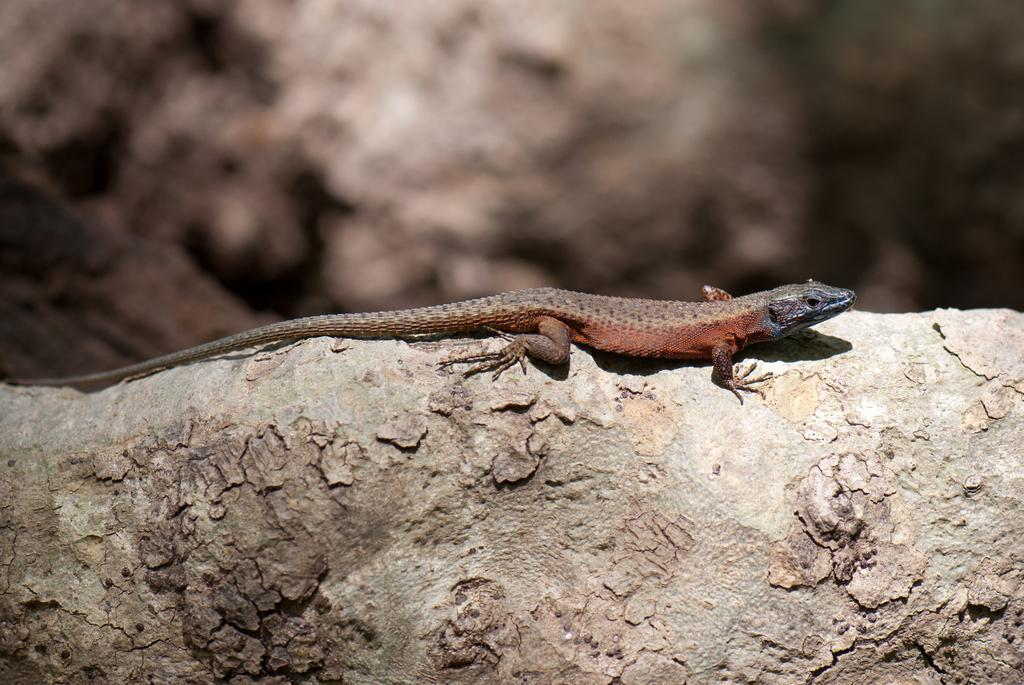What is the focus of the image, considering the background is blurred? The focus of the image is likely the reptile, as the background is blurred. What type of animal is present in the image? There is a reptile in the image. Where is the reptile located in the image? The reptile is on a wooden branch. How many cherries are hanging from the reptile's tail in the image? There are no cherries present in the image, and the reptile's tail is not visible. 